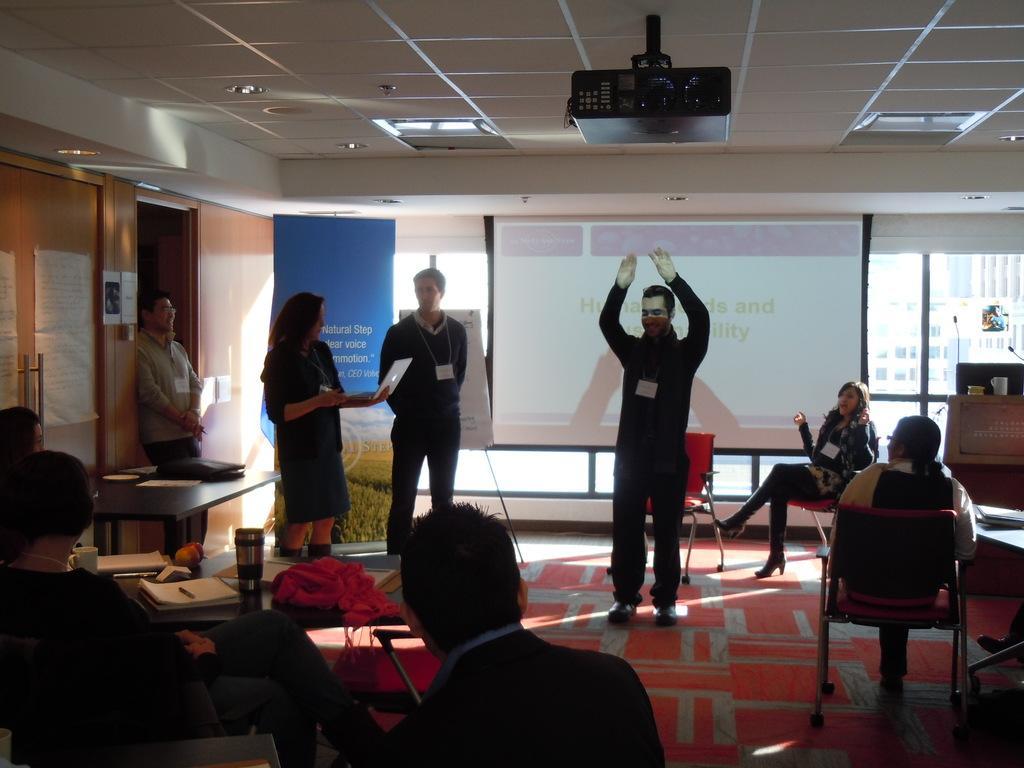In one or two sentences, can you explain what this image depicts? In this image in the front there are persons sitting. In the center there are persons standing and in the background there are boards with some text, there is a window, behind the window there are buildings, there is an empty chair. On the top there is a projector. On the left side there is a door and on the right side there is a table on the table there are objects. In the background there is a table and on the table there is a cup. 